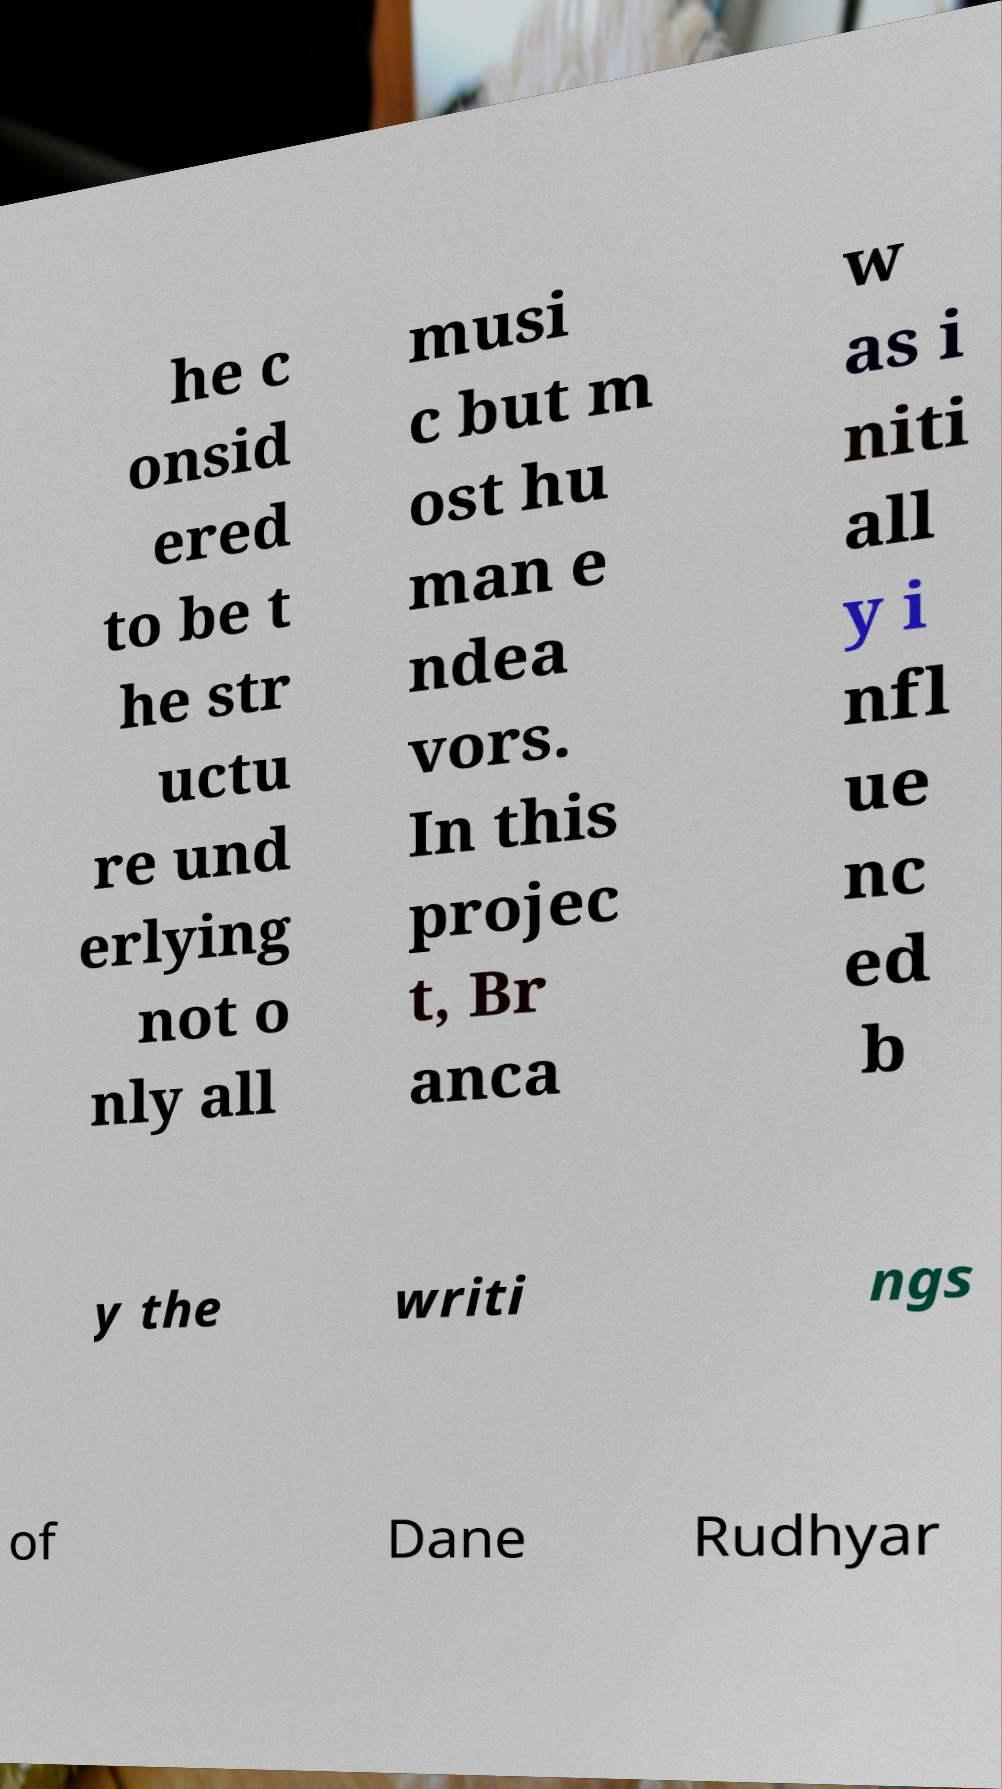What messages or text are displayed in this image? I need them in a readable, typed format. he c onsid ered to be t he str uctu re und erlying not o nly all musi c but m ost hu man e ndea vors. In this projec t, Br anca w as i niti all y i nfl ue nc ed b y the writi ngs of Dane Rudhyar 